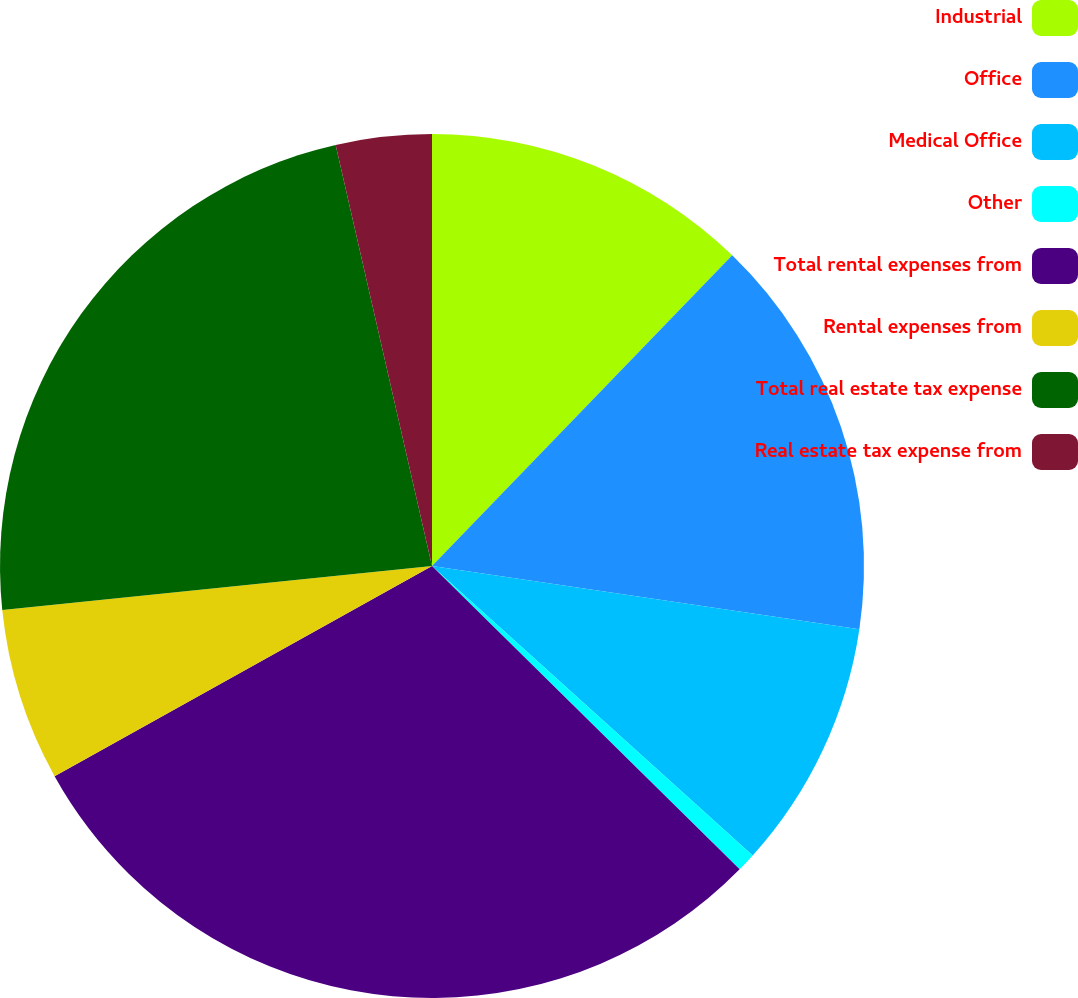Convert chart to OTSL. <chart><loc_0><loc_0><loc_500><loc_500><pie_chart><fcel>Industrial<fcel>Office<fcel>Medical Office<fcel>Other<fcel>Total rental expenses from<fcel>Rental expenses from<fcel>Total real estate tax expense<fcel>Real estate tax expense from<nl><fcel>12.23%<fcel>15.11%<fcel>9.35%<fcel>0.7%<fcel>29.53%<fcel>6.46%<fcel>23.05%<fcel>3.58%<nl></chart> 